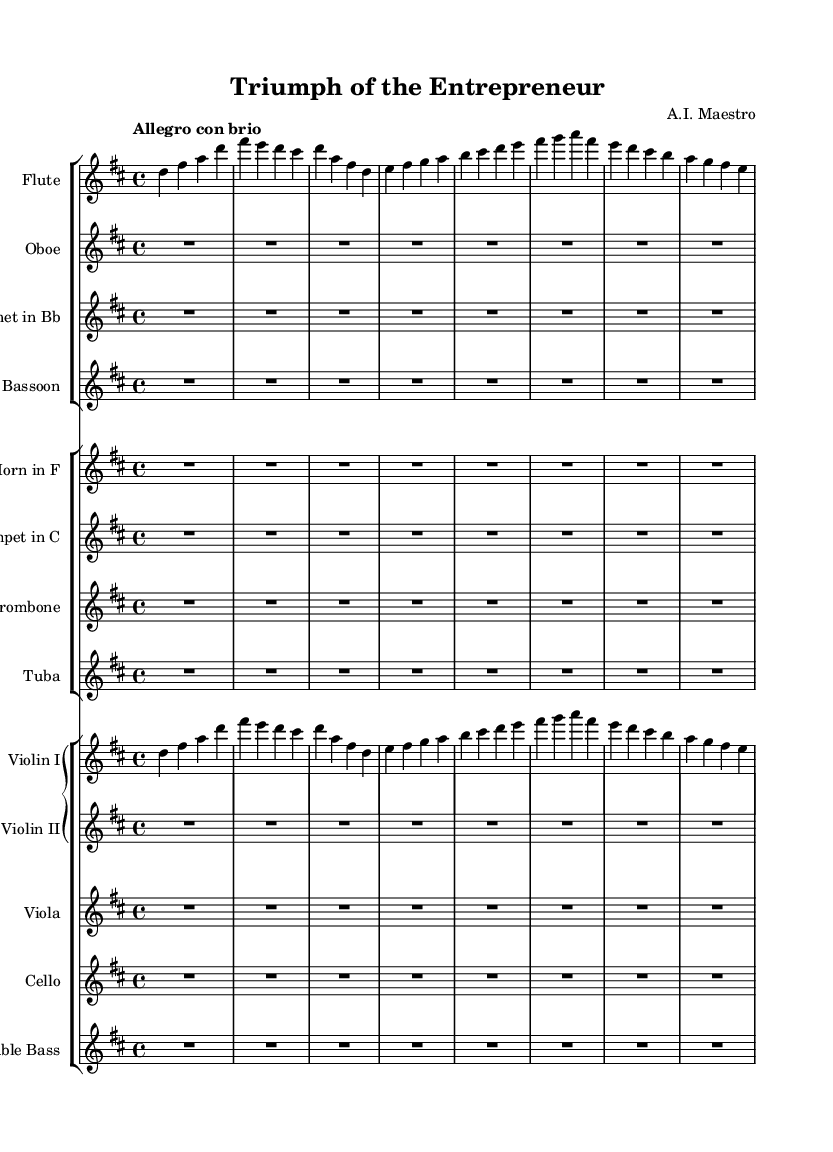What is the key signature of this music? The key signature is D major, which has two sharps: F sharp and C sharp. This is indicated at the beginning of the staff on the clefs.
Answer: D major What is the time signature of this composition? The time signature is 4/4, meaning there are four beats in each measure and the quarter note receives one beat. This is printed at the start of the score.
Answer: 4/4 What is the indicated tempo for this piece? The tempo marking found at the beginning of the score is "Allegro con brio," which suggests a brisk and lively pace. This phrase is placed above the staff.
Answer: Allegro con brio How many measures are there in the flute part? By counting the measures in the flute part, we find there are six measures notated. Each measure is visually distinct by vertical lines separating them.
Answer: 6 Which instruments are explicitly notated in the score? The score specifically notates the flute, oboe, clarinet, bassoon, horn, trumpet, trombone, tuba, violin I, violin II, viola, cello, and double bass, indicated by the instrument names at the beginning of their respective staves.
Answer: Flute, oboe, clarinet, bassoon, horn, trumpet, trombone, tuba, violin I, violin II, viola, cello, double bass What is the theme represented by the flute and violin I parts? The themes in both the flute and violin I parts are identical, with the flutes playing the same melodic phrase as violins, emphasizing unity in the musical message. The phrases are aligned vertically across staves.
Answer: Identity 